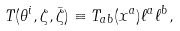Convert formula to latex. <formula><loc_0><loc_0><loc_500><loc_500>T ( \theta ^ { i } , \zeta , \bar { \zeta } ) \equiv T _ { a b } ( x ^ { a } ) \ell ^ { a } \ell ^ { b } ,</formula> 